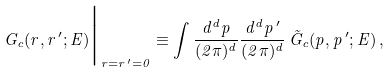<formula> <loc_0><loc_0><loc_500><loc_500>G _ { c } ( { r } , { r } ^ { \, \prime } ; E ) \Big | _ { { r } = { r } ^ { \, \prime } = { 0 } } \equiv \int \frac { d ^ { d } { p } } { ( 2 \pi ) ^ { d } } \frac { d ^ { d } { p } ^ { \, \prime } } { ( 2 \pi ) ^ { d } } \, \tilde { G } _ { c } ( { p } , { p } ^ { \, \prime } ; E ) \, ,</formula> 